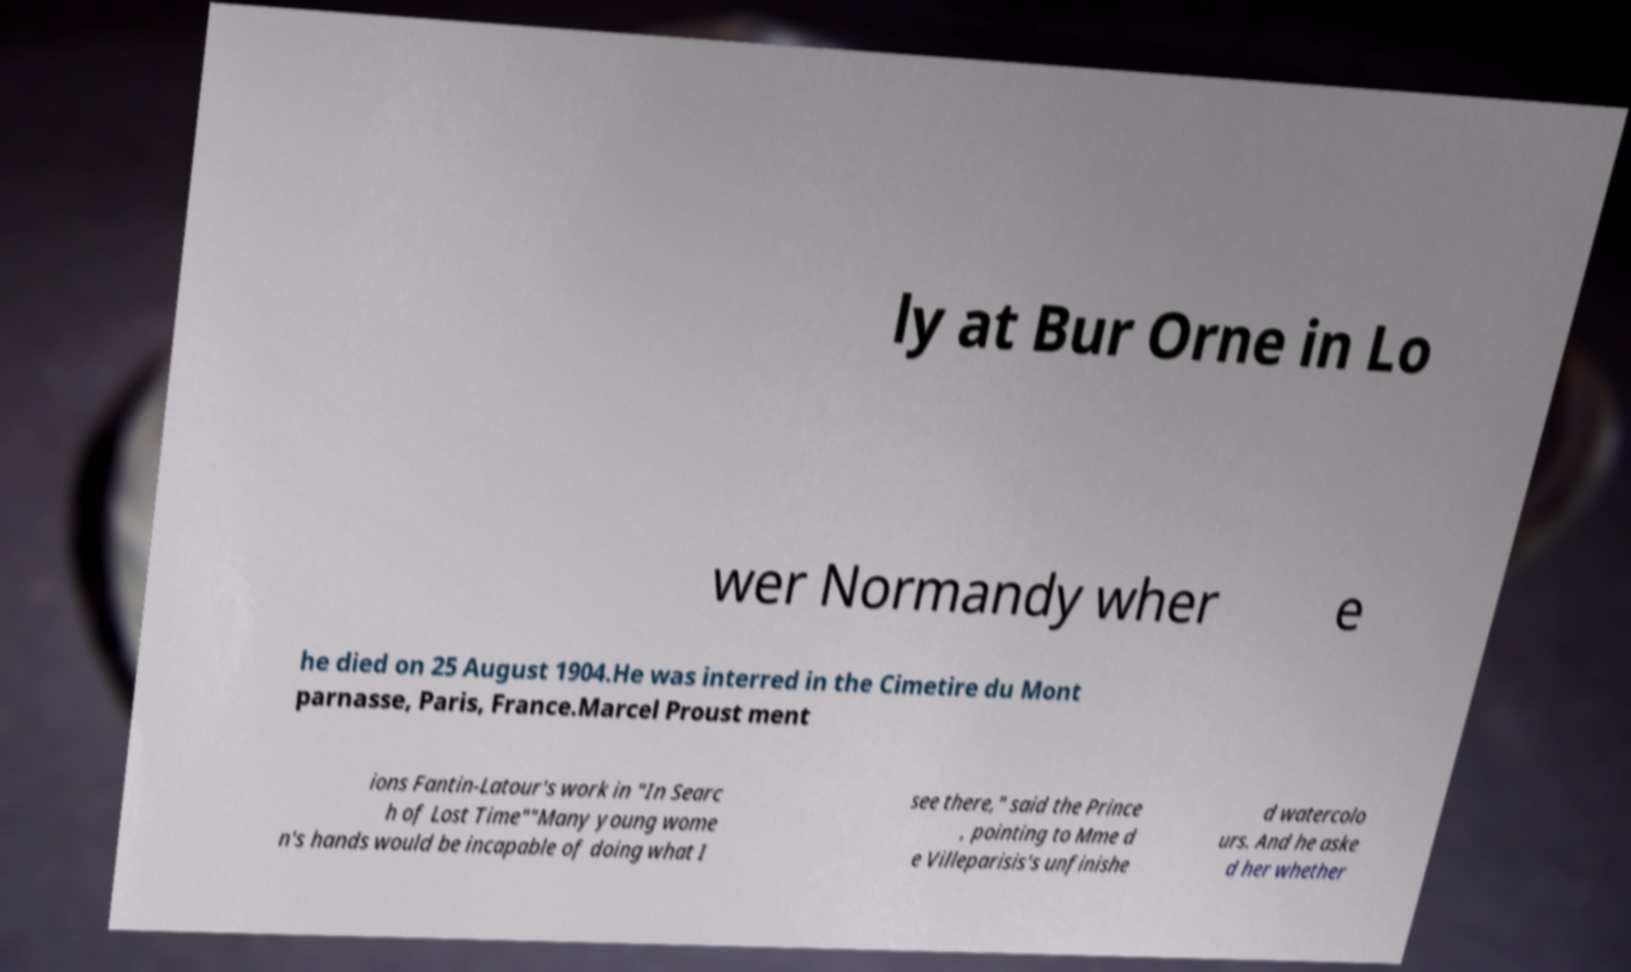I need the written content from this picture converted into text. Can you do that? ly at Bur Orne in Lo wer Normandy wher e he died on 25 August 1904.He was interred in the Cimetire du Mont parnasse, Paris, France.Marcel Proust ment ions Fantin-Latour's work in "In Searc h of Lost Time""Many young wome n's hands would be incapable of doing what I see there," said the Prince , pointing to Mme d e Villeparisis's unfinishe d watercolo urs. And he aske d her whether 